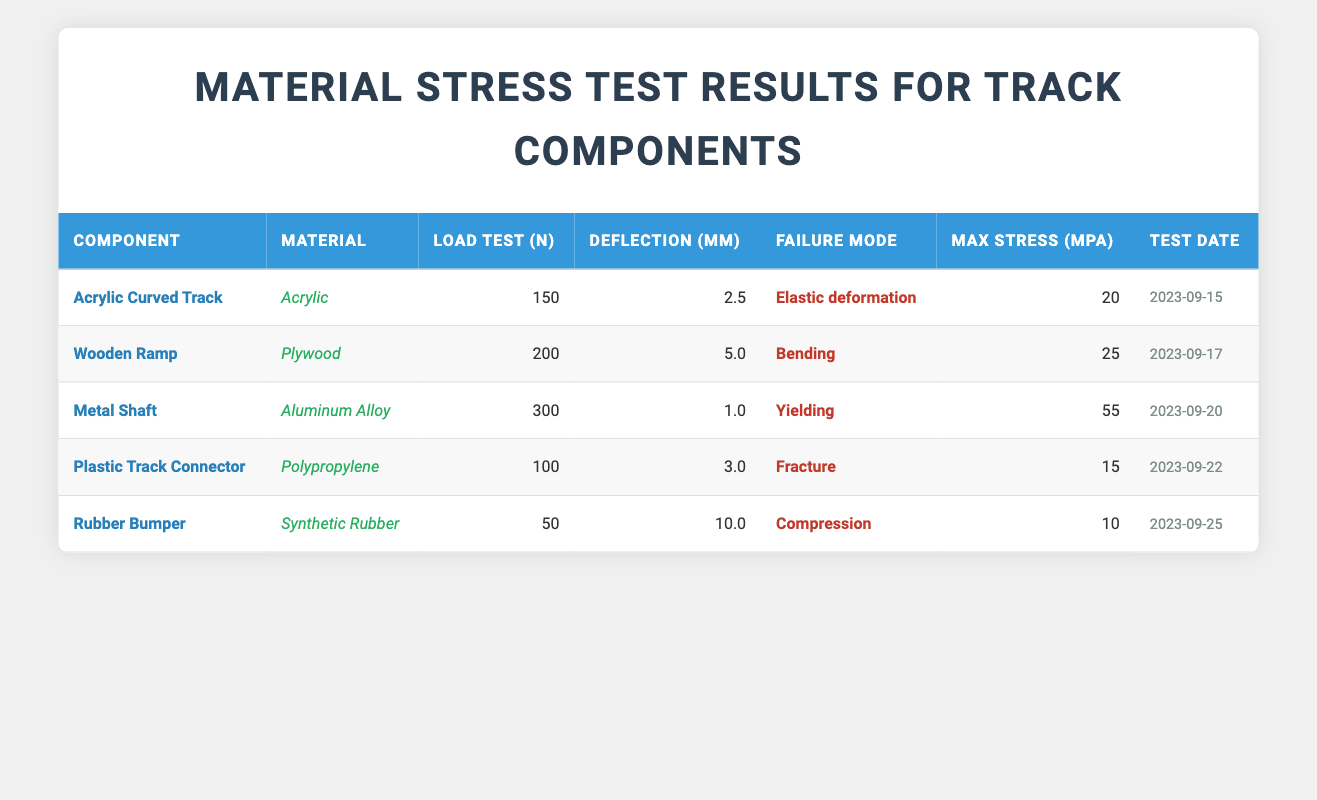What is the maximum load test value for the Wooden Ramp? The maximum load test value is listed in the "Load Test (N)" column for the Wooden Ramp component. The value is 200 N as indicated in the table.
Answer: 200 N What is the deflection for the Acrylic Curved Track? The deflection value can be found in the "Deflection (mm)" column for the Acrylic Curved Track component, which is 2.5 mm according to the table.
Answer: 2.5 mm Is the maximum stress for the Rubber Bumper greater than 15 MPa? Looking at the "Max Stress (MPa)" column, the value for Rubber Bumper is 10 MPa, which is less than 15 MPa. Therefore, the statement is false.
Answer: No How many components have a failure mode of bending? By inspecting the "Failure Mode" column, there is only one component listed with a failure mode of bending, which is the Wooden Ramp.
Answer: 1 What is the average maximum stress of all tested components? To find the average, we first sum the maximum stress values: 20 + 25 + 55 + 15 + 10 = 125 MPa. Then, we divide by the number of components, which is 5, yielding an average maximum stress of 125/5 = 25 MPa.
Answer: 25 MPa Which component has the highest deflection, and what is its value? By comparing the values in the "Deflection (mm)" column, the Rubber Bumper has the highest deflection at 10 mm, as this is the largest value in that column.
Answer: Rubber Bumper, 10 mm Does the Metal Shaft have a failure mode of elastic deformation? Upon reviewing the "Failure Mode" column, the Metal Shaft's failure mode is listed as yielding, not elastic deformation. Thus, the statement is false.
Answer: No What is the difference in maximum stress between the Metal Shaft and Acrylic Curved Track? First, we note the maximum stress values: Metal Shaft is 55 MPa and Acrylic Curved Track is 20 MPa. The difference is calculated as 55 - 20 = 35 MPa.
Answer: 35 MPa 